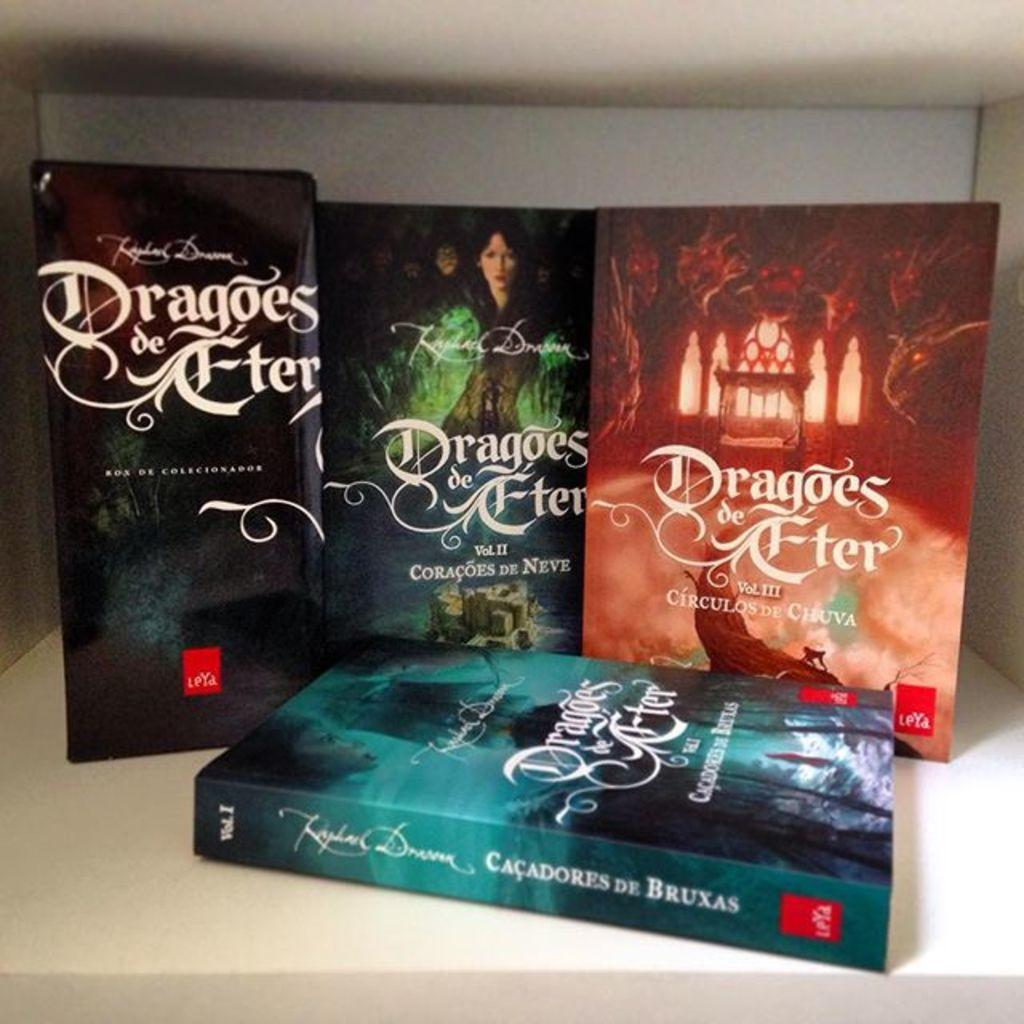<image>
Share a concise interpretation of the image provided. The book collection of Dragoes de Fter  by Coracoes De Neve 